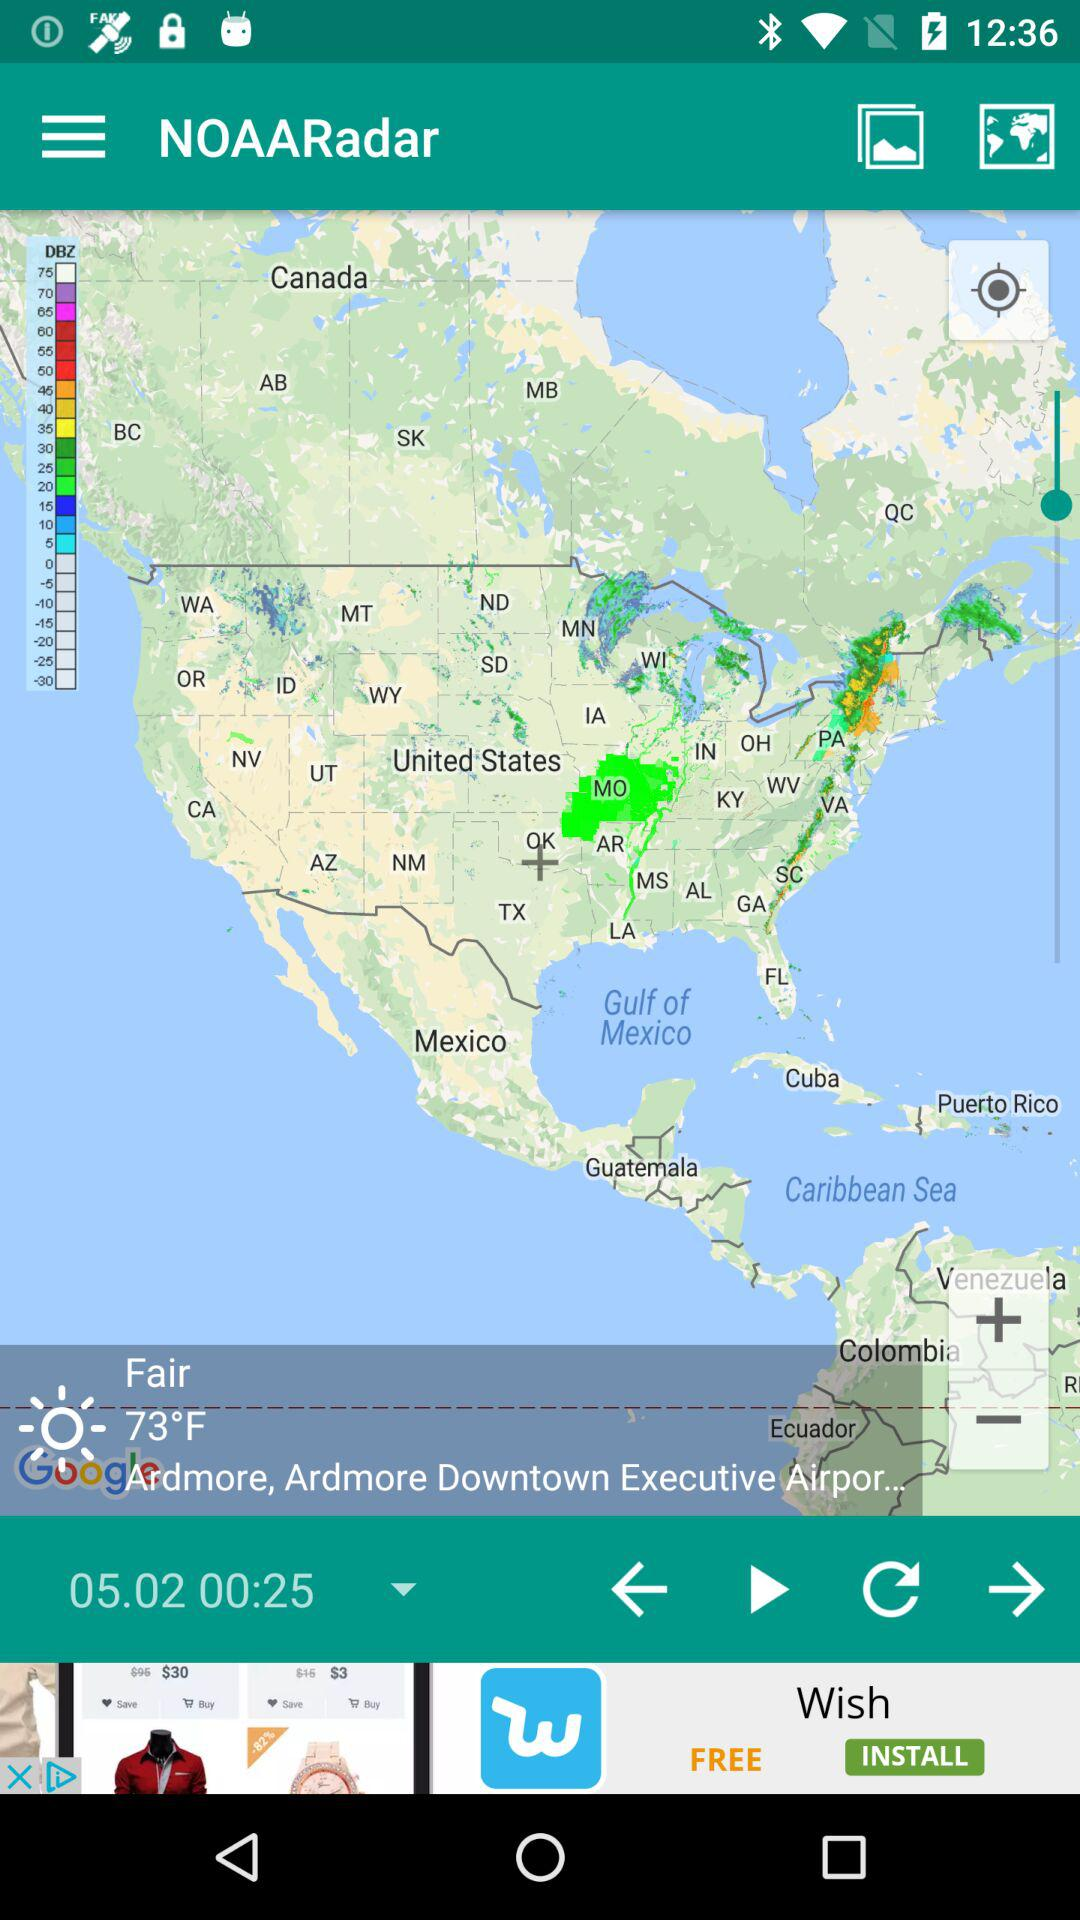How's the weather? The weather is fair. 